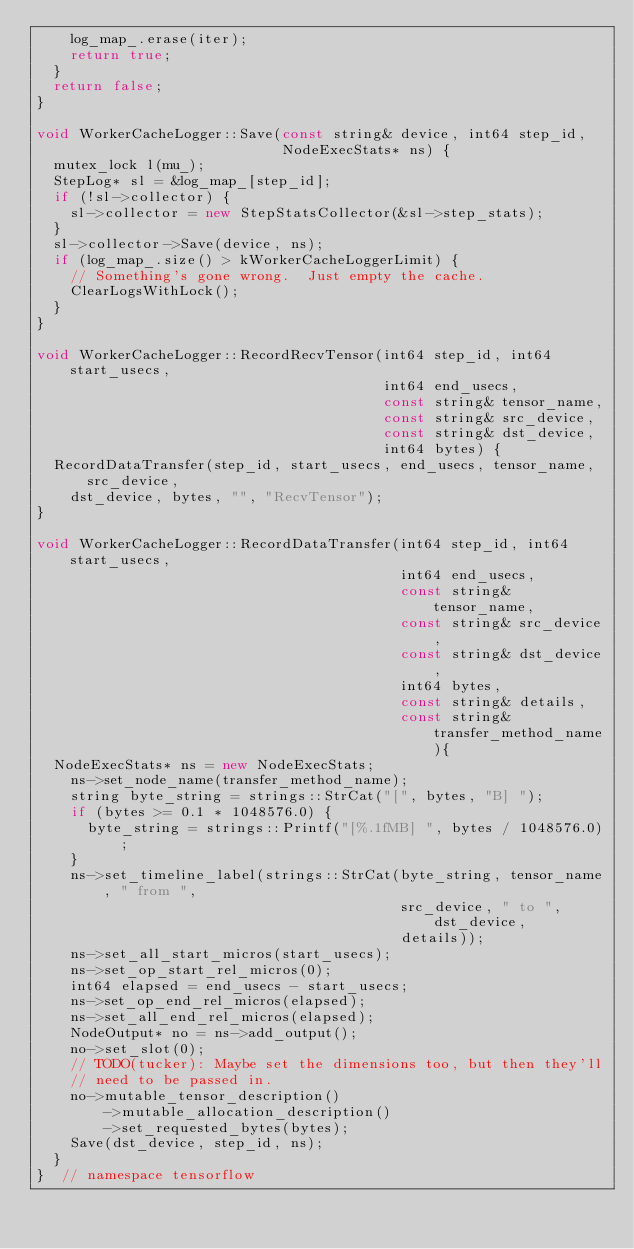<code> <loc_0><loc_0><loc_500><loc_500><_C++_>    log_map_.erase(iter);
    return true;
  }
  return false;
}

void WorkerCacheLogger::Save(const string& device, int64 step_id,
                             NodeExecStats* ns) {
  mutex_lock l(mu_);
  StepLog* sl = &log_map_[step_id];
  if (!sl->collector) {
    sl->collector = new StepStatsCollector(&sl->step_stats);
  }
  sl->collector->Save(device, ns);
  if (log_map_.size() > kWorkerCacheLoggerLimit) {
    // Something's gone wrong.  Just empty the cache.
    ClearLogsWithLock();
  }
}

void WorkerCacheLogger::RecordRecvTensor(int64 step_id, int64 start_usecs,
                                         int64 end_usecs,
                                         const string& tensor_name,
                                         const string& src_device,
                                         const string& dst_device,
                                         int64 bytes) {
  RecordDataTransfer(step_id, start_usecs, end_usecs, tensor_name, src_device,
    dst_device, bytes, "", "RecvTensor");
}

void WorkerCacheLogger::RecordDataTransfer(int64 step_id, int64 start_usecs,
                                           int64 end_usecs,
                                           const string& tensor_name,
                                           const string& src_device,
                                           const string& dst_device,
                                           int64 bytes,
                                           const string& details,
                                           const string& transfer_method_name){
  NodeExecStats* ns = new NodeExecStats;
    ns->set_node_name(transfer_method_name);
    string byte_string = strings::StrCat("[", bytes, "B] ");
    if (bytes >= 0.1 * 1048576.0) {
      byte_string = strings::Printf("[%.1fMB] ", bytes / 1048576.0);
    }
    ns->set_timeline_label(strings::StrCat(byte_string, tensor_name, " from ",
                                           src_device, " to ", dst_device,
                                           details));
    ns->set_all_start_micros(start_usecs);
    ns->set_op_start_rel_micros(0);
    int64 elapsed = end_usecs - start_usecs;
    ns->set_op_end_rel_micros(elapsed);
    ns->set_all_end_rel_micros(elapsed);
    NodeOutput* no = ns->add_output();
    no->set_slot(0);
    // TODO(tucker): Maybe set the dimensions too, but then they'll
    // need to be passed in.
    no->mutable_tensor_description()
        ->mutable_allocation_description()
        ->set_requested_bytes(bytes);
    Save(dst_device, step_id, ns);
  }
}  // namespace tensorflow
</code> 